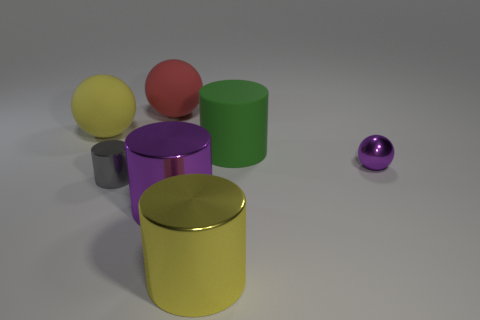Subtract 1 cylinders. How many cylinders are left? 3 Add 1 tiny cylinders. How many objects exist? 8 Subtract all cylinders. How many objects are left? 3 Add 7 big balls. How many big balls are left? 9 Add 6 large gray cylinders. How many large gray cylinders exist? 6 Subtract 0 red cylinders. How many objects are left? 7 Subtract all small purple shiny objects. Subtract all purple cylinders. How many objects are left? 5 